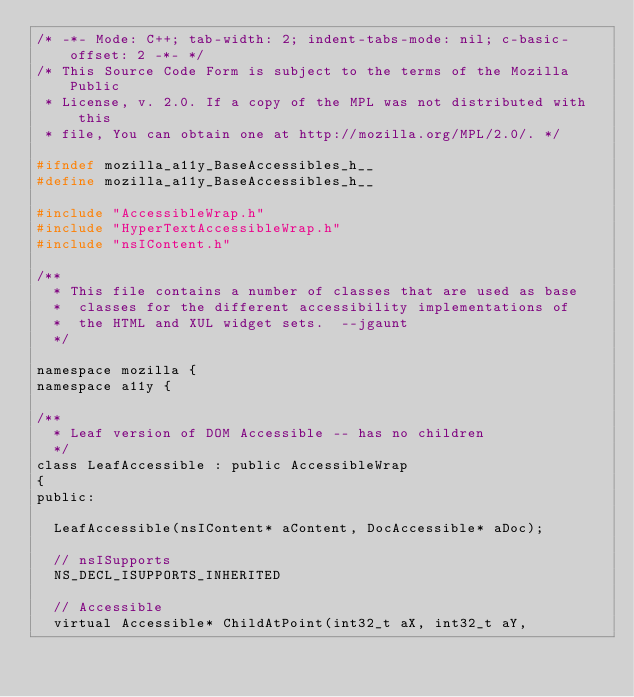<code> <loc_0><loc_0><loc_500><loc_500><_C_>/* -*- Mode: C++; tab-width: 2; indent-tabs-mode: nil; c-basic-offset: 2 -*- */
/* This Source Code Form is subject to the terms of the Mozilla Public
 * License, v. 2.0. If a copy of the MPL was not distributed with this
 * file, You can obtain one at http://mozilla.org/MPL/2.0/. */

#ifndef mozilla_a11y_BaseAccessibles_h__
#define mozilla_a11y_BaseAccessibles_h__

#include "AccessibleWrap.h"
#include "HyperTextAccessibleWrap.h"
#include "nsIContent.h"

/**
  * This file contains a number of classes that are used as base
  *  classes for the different accessibility implementations of
  *  the HTML and XUL widget sets.  --jgaunt
  */

namespace mozilla {
namespace a11y {

/**
  * Leaf version of DOM Accessible -- has no children
  */
class LeafAccessible : public AccessibleWrap
{
public:

  LeafAccessible(nsIContent* aContent, DocAccessible* aDoc);

  // nsISupports
  NS_DECL_ISUPPORTS_INHERITED

  // Accessible
  virtual Accessible* ChildAtPoint(int32_t aX, int32_t aY,</code> 